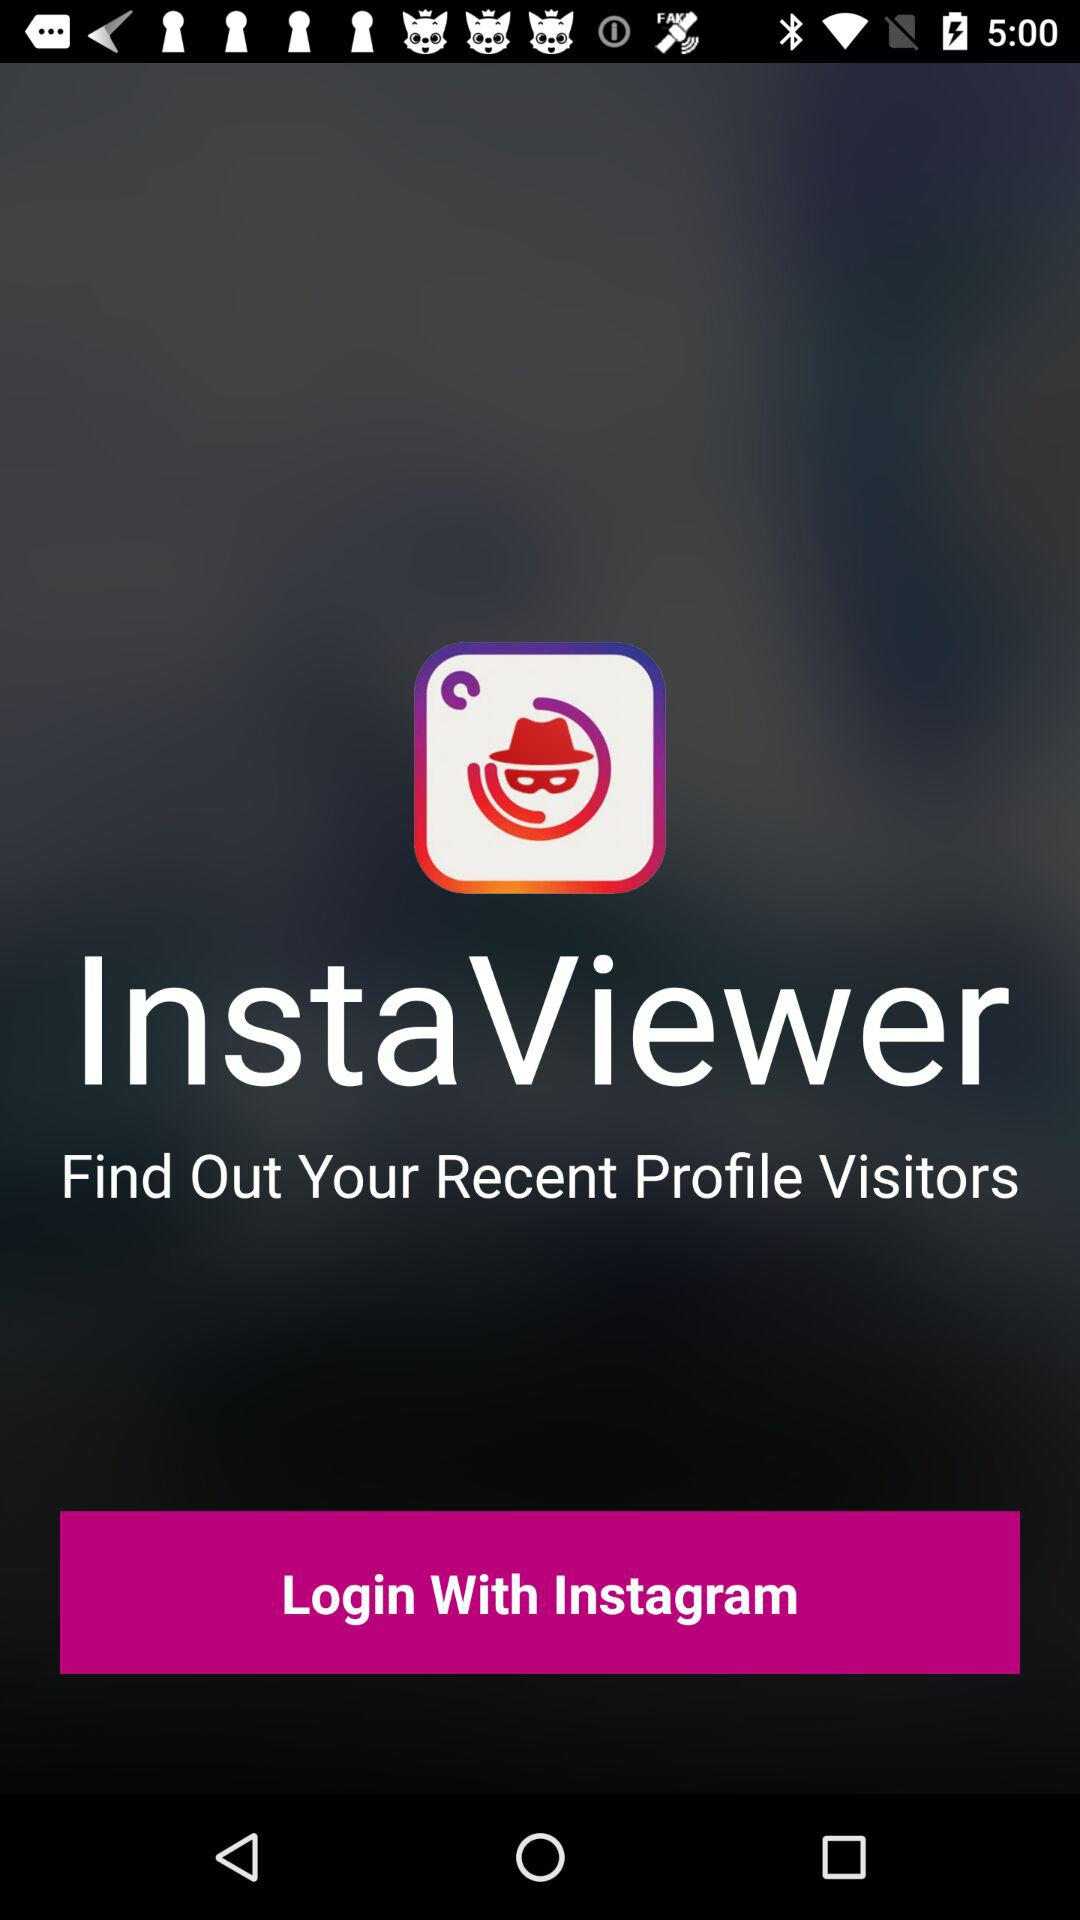What is the application name? The application name is "InstaViewer". 